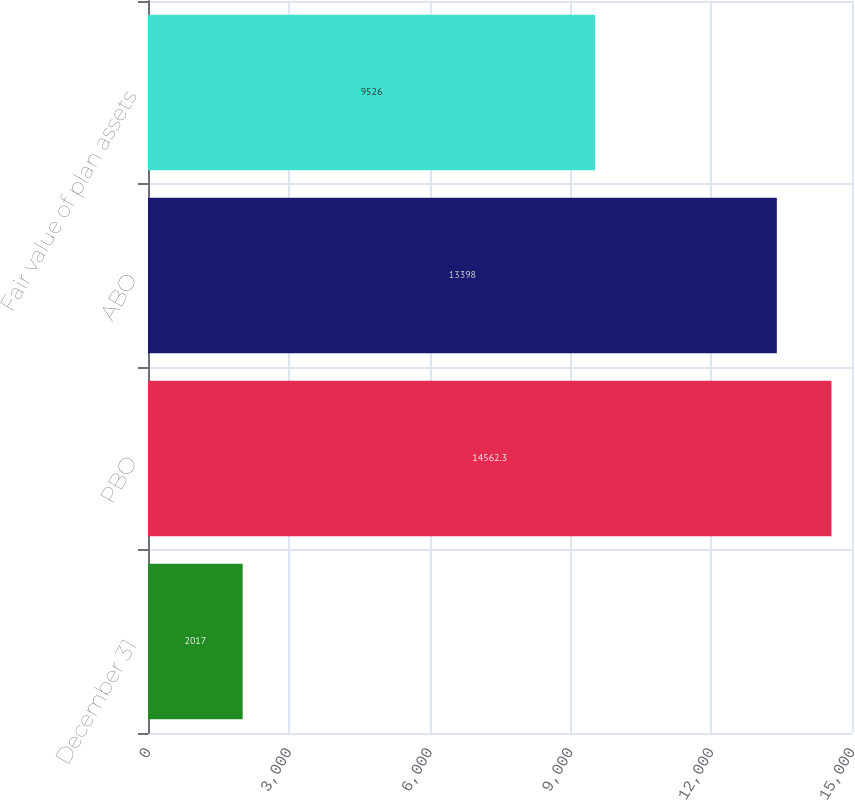Convert chart to OTSL. <chart><loc_0><loc_0><loc_500><loc_500><bar_chart><fcel>December 31<fcel>PBO<fcel>ABO<fcel>Fair value of plan assets<nl><fcel>2017<fcel>14562.3<fcel>13398<fcel>9526<nl></chart> 